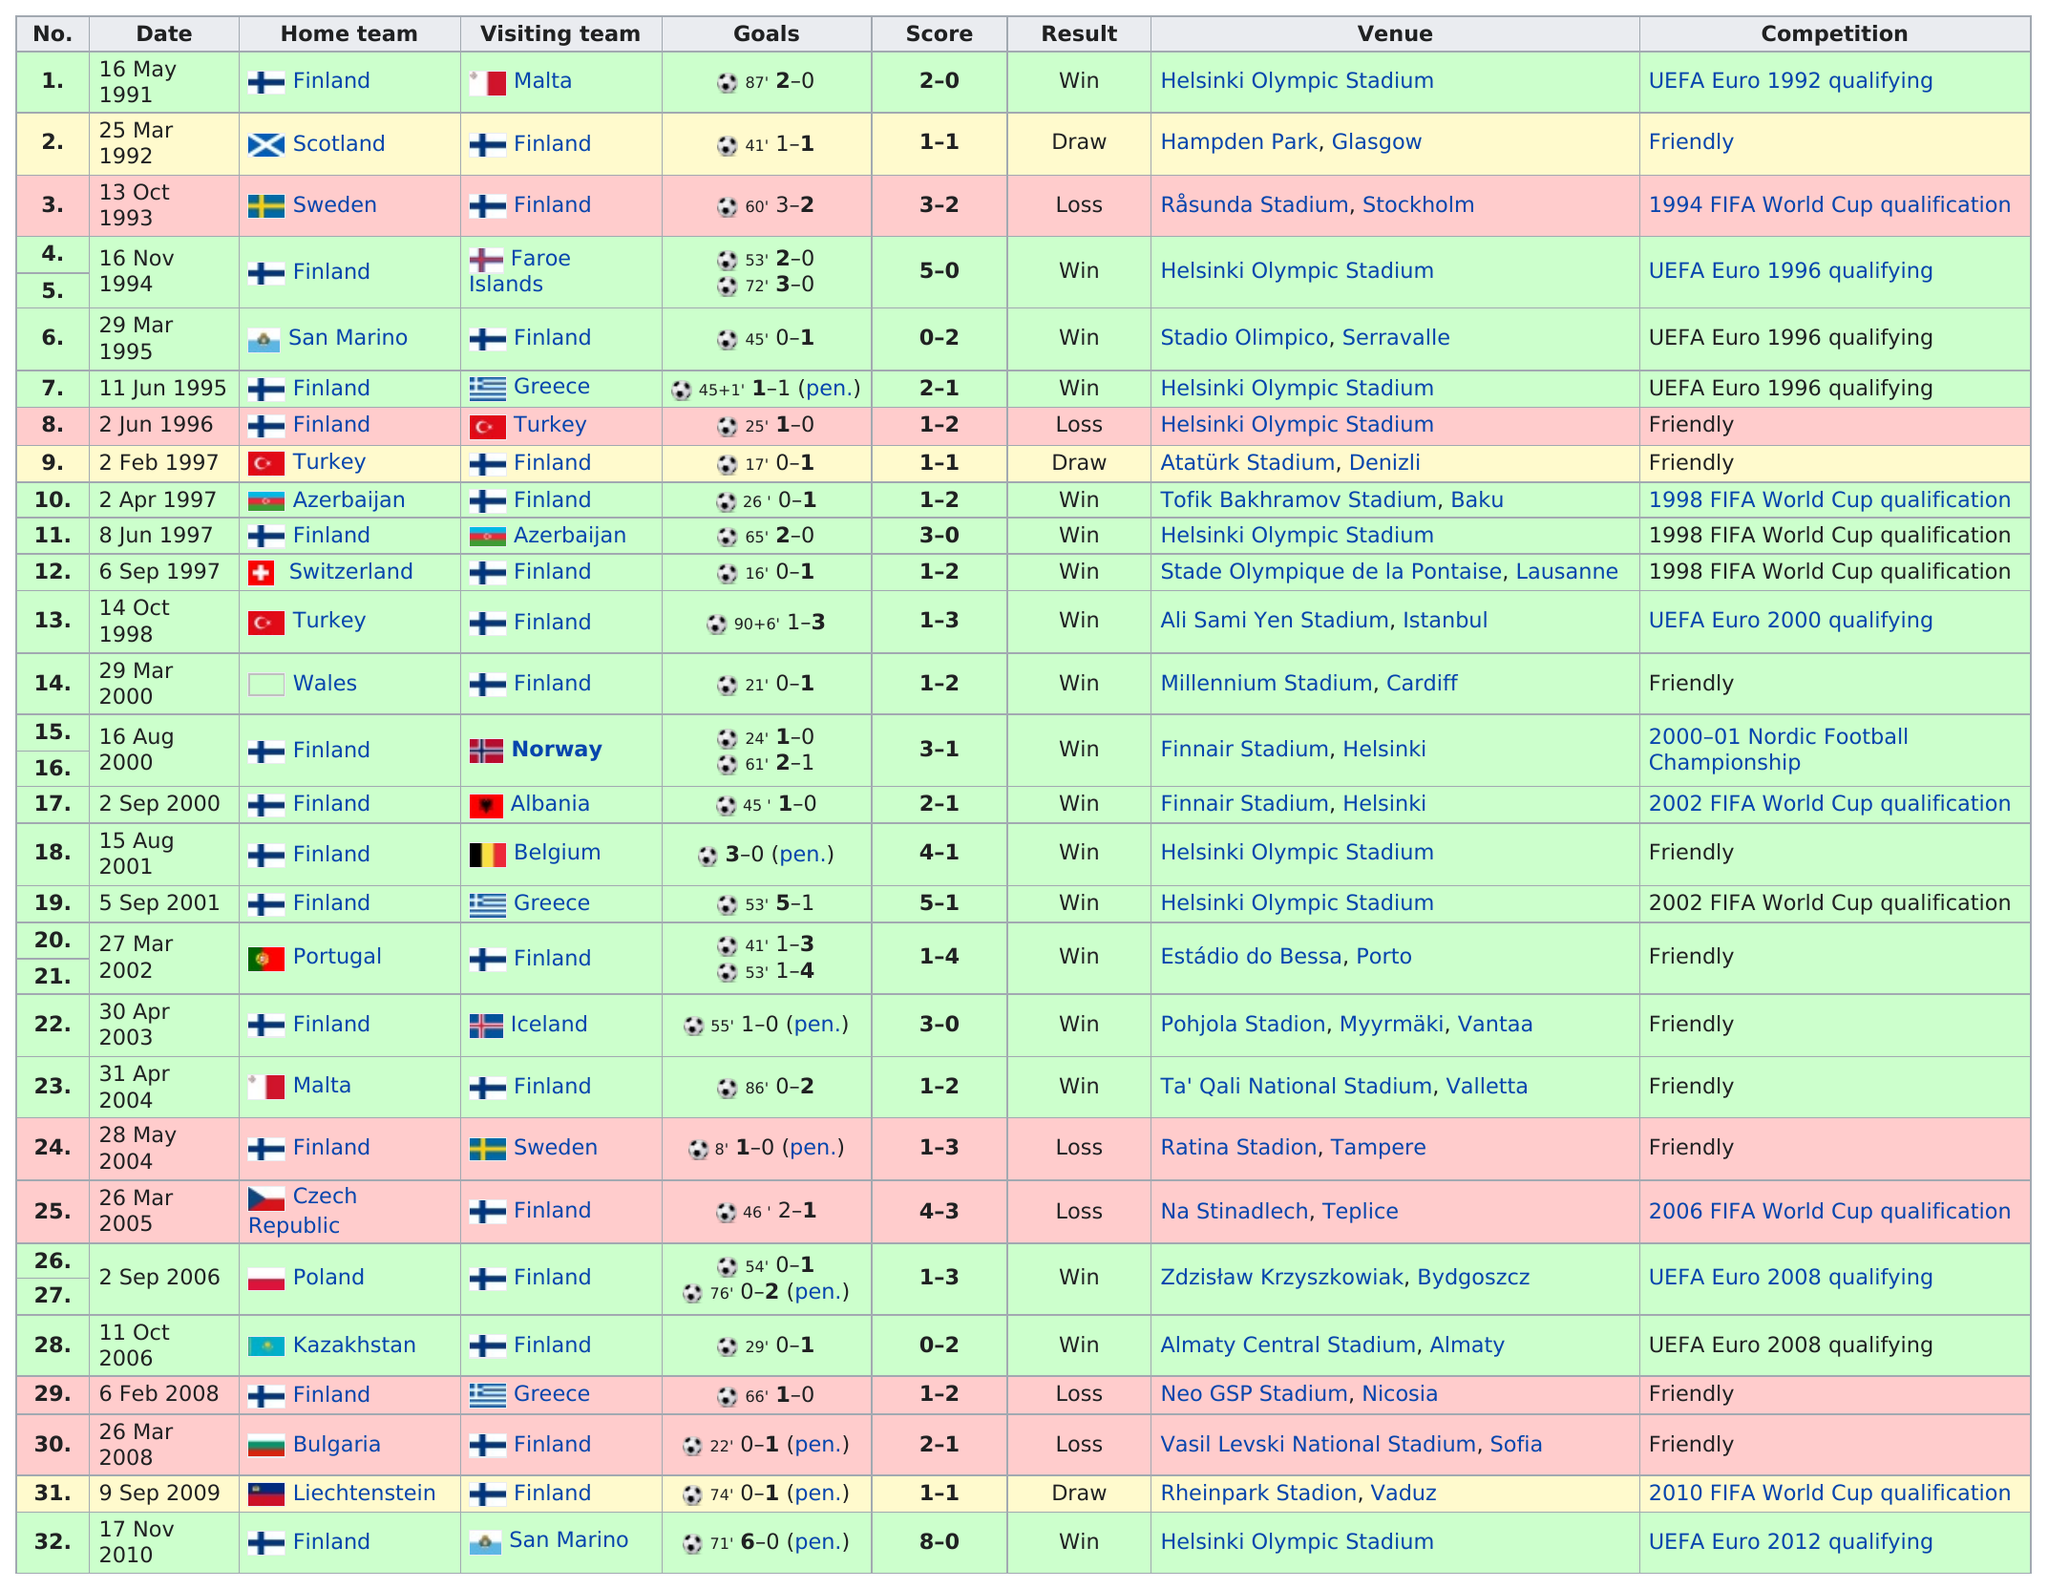Outline some significant characteristics in this image. It was approximately 10 months between Jari Litmanen's first and second international goals. In March, the total number of dates listed was 6. Helsinki Olympic Stadium served as the venue for the Olympics eight times. In total, there were three games in which one team won by more than three points. In the year 1995, Finland faced Greece for the first time. 